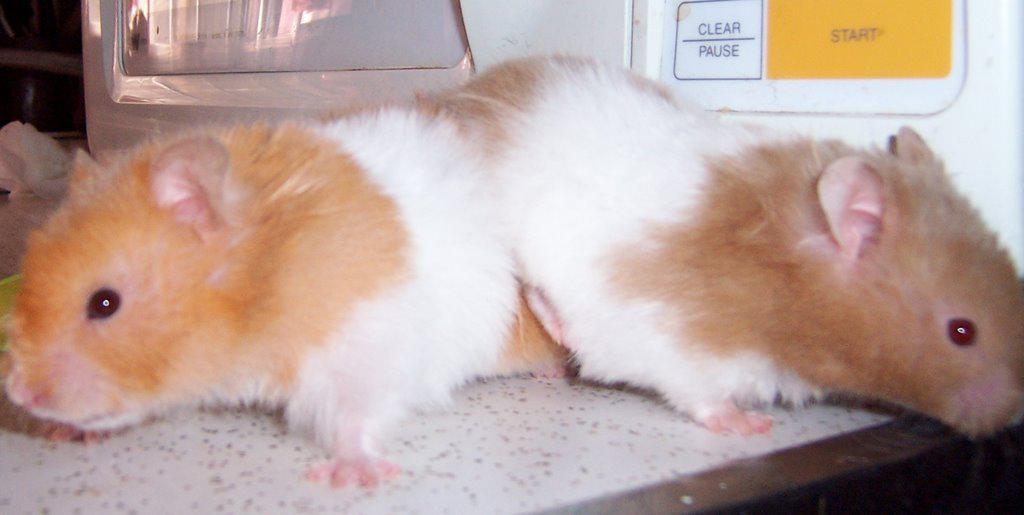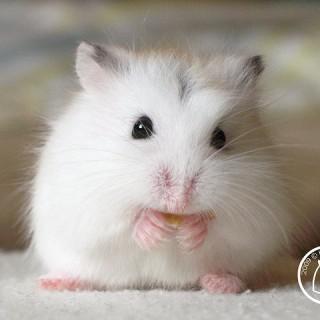The first image is the image on the left, the second image is the image on the right. Considering the images on both sides, is "Some of the hamsters are asleep." valid? Answer yes or no. No. The first image is the image on the left, the second image is the image on the right. For the images shown, is this caption "The left image shows two hamsters sleeping side-by-side with their eyes shut and paws facing upward." true? Answer yes or no. No. 